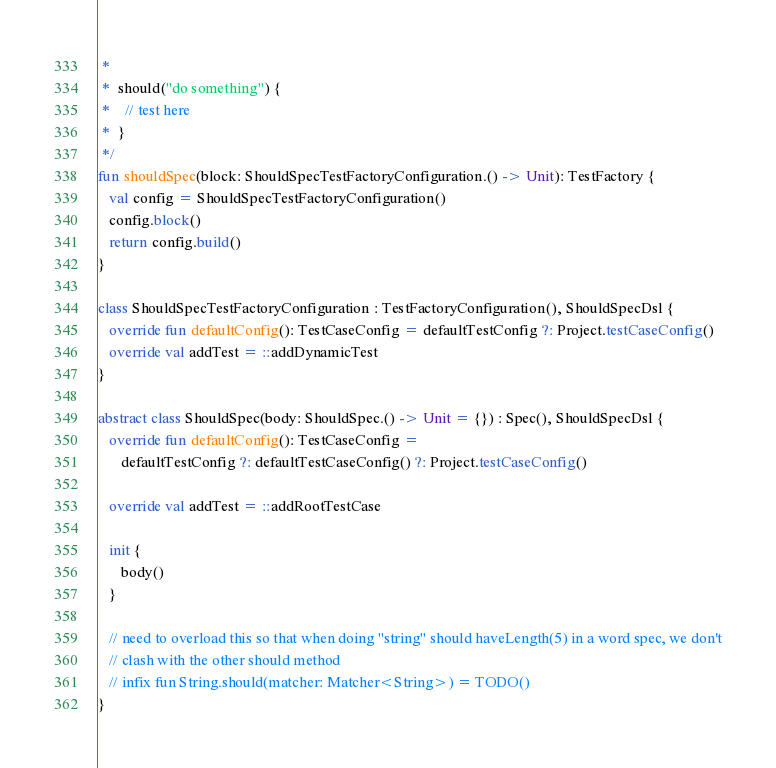<code> <loc_0><loc_0><loc_500><loc_500><_Kotlin_> *
 *  should("do something") {
 *    // test here
 *  }
 */
fun shouldSpec(block: ShouldSpecTestFactoryConfiguration.() -> Unit): TestFactory {
   val config = ShouldSpecTestFactoryConfiguration()
   config.block()
   return config.build()
}

class ShouldSpecTestFactoryConfiguration : TestFactoryConfiguration(), ShouldSpecDsl {
   override fun defaultConfig(): TestCaseConfig = defaultTestConfig ?: Project.testCaseConfig()
   override val addTest = ::addDynamicTest
}

abstract class ShouldSpec(body: ShouldSpec.() -> Unit = {}) : Spec(), ShouldSpecDsl {
   override fun defaultConfig(): TestCaseConfig =
      defaultTestConfig ?: defaultTestCaseConfig() ?: Project.testCaseConfig()

   override val addTest = ::addRootTestCase

   init {
      body()
   }

   // need to overload this so that when doing "string" should haveLength(5) in a word spec, we don't
   // clash with the other should method
   // infix fun String.should(matcher: Matcher<String>) = TODO()
}
</code> 